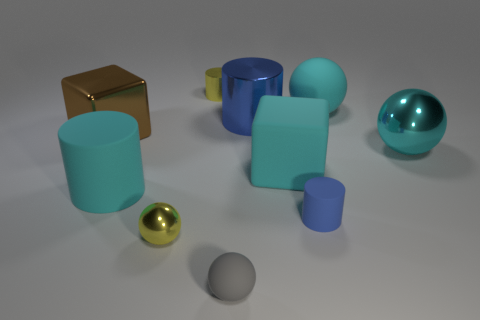What materials are the objects in the image made from? The objects in the image appear to have surfaces that mimic different materials. The spheres and the cube have reflective finishes suggestive of metallic or polished surfaces, while the cylinders look like they have matte finishes, possibly simulating plastic or painted surfaces. 